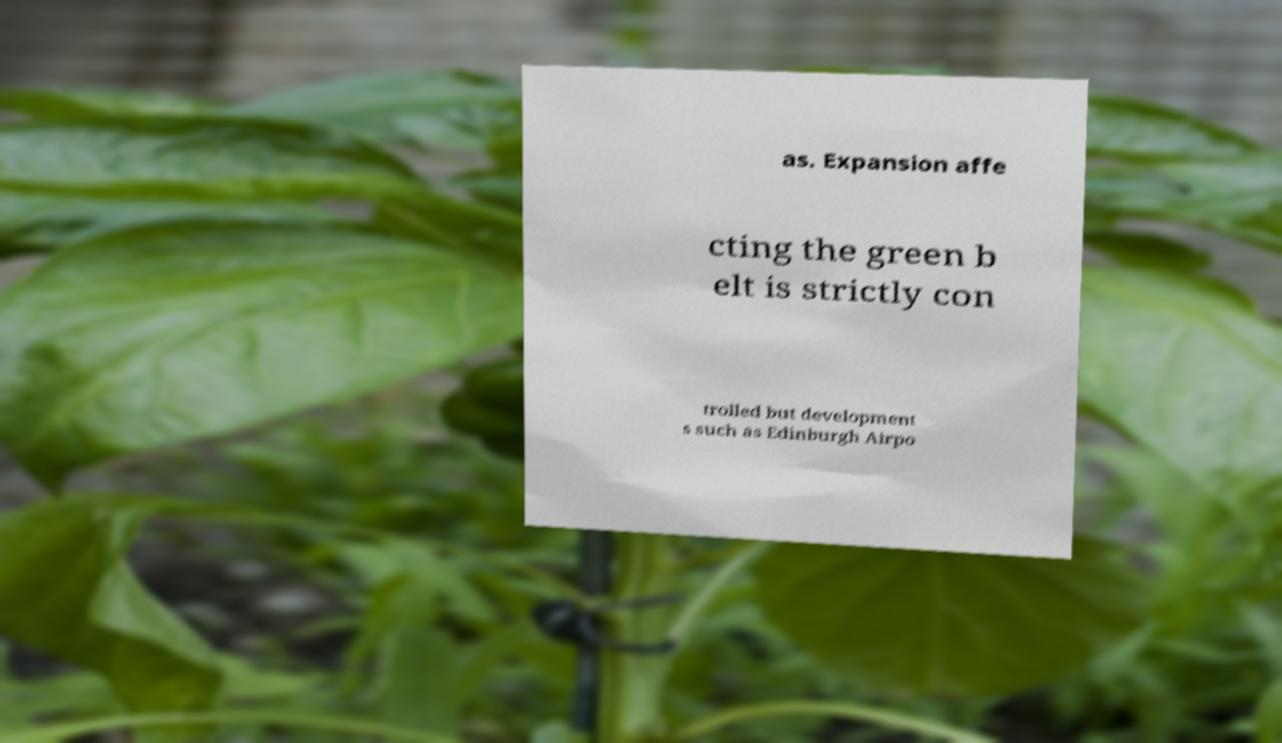I need the written content from this picture converted into text. Can you do that? as. Expansion affe cting the green b elt is strictly con trolled but development s such as Edinburgh Airpo 